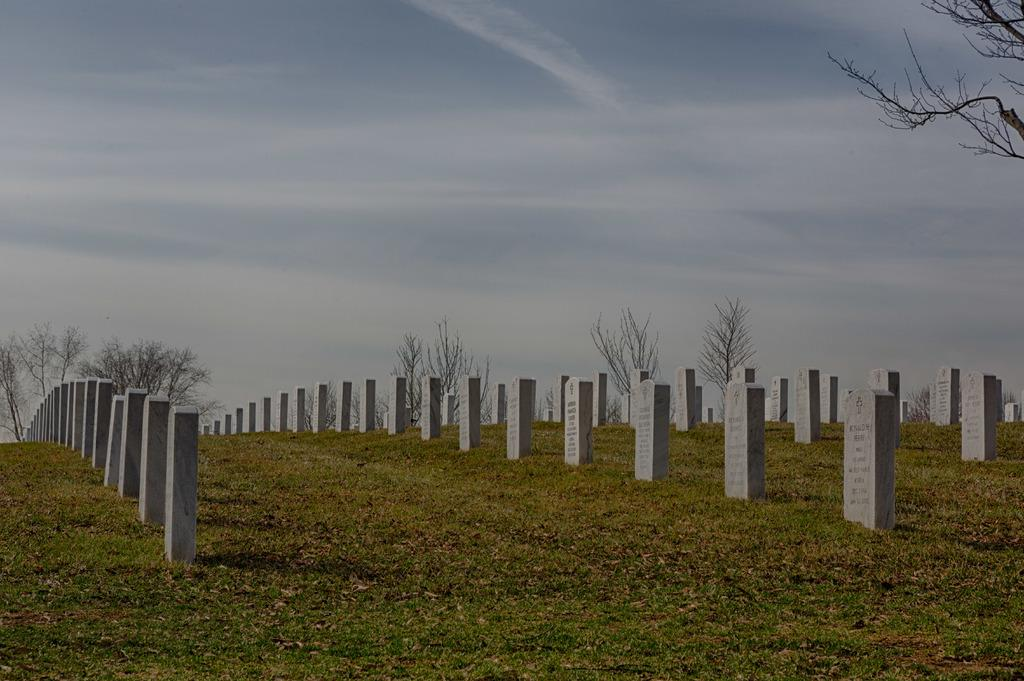What type of objects can be seen in the image? There are memorial stones in the image. What is the ground surface like in the image? Grass is present in the image. What else can be found on the ground in the image? Dry leaves are visible in the image. What type of vegetation is present in the image? There are trees in the image. What is the condition of the sky in the background? The sky in the background is cloudy. How does the elbow contribute to the appearance of the image? There is no mention of an elbow in the image, so it does not contribute to the appearance. 